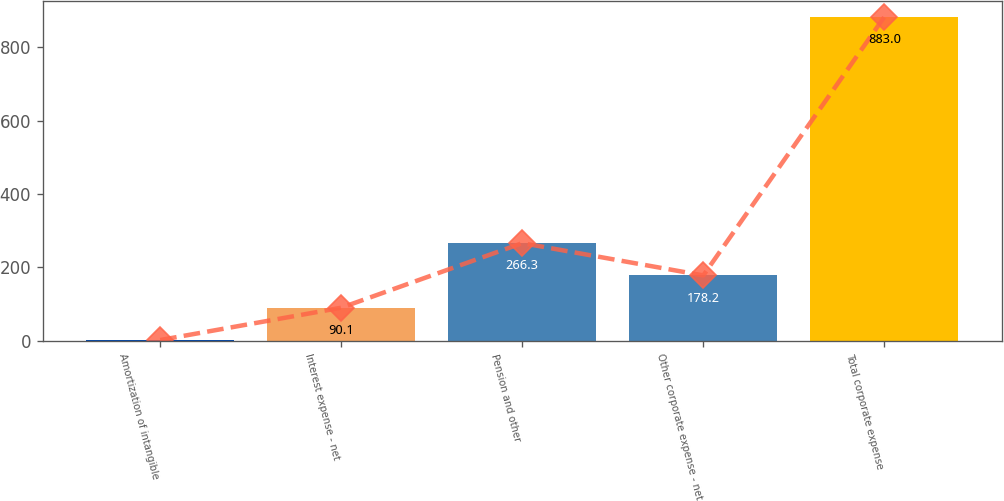Convert chart. <chart><loc_0><loc_0><loc_500><loc_500><bar_chart><fcel>Amortization of intangible<fcel>Interest expense - net<fcel>Pension and other<fcel>Other corporate expense - net<fcel>Total corporate expense<nl><fcel>2<fcel>90.1<fcel>266.3<fcel>178.2<fcel>883<nl></chart> 